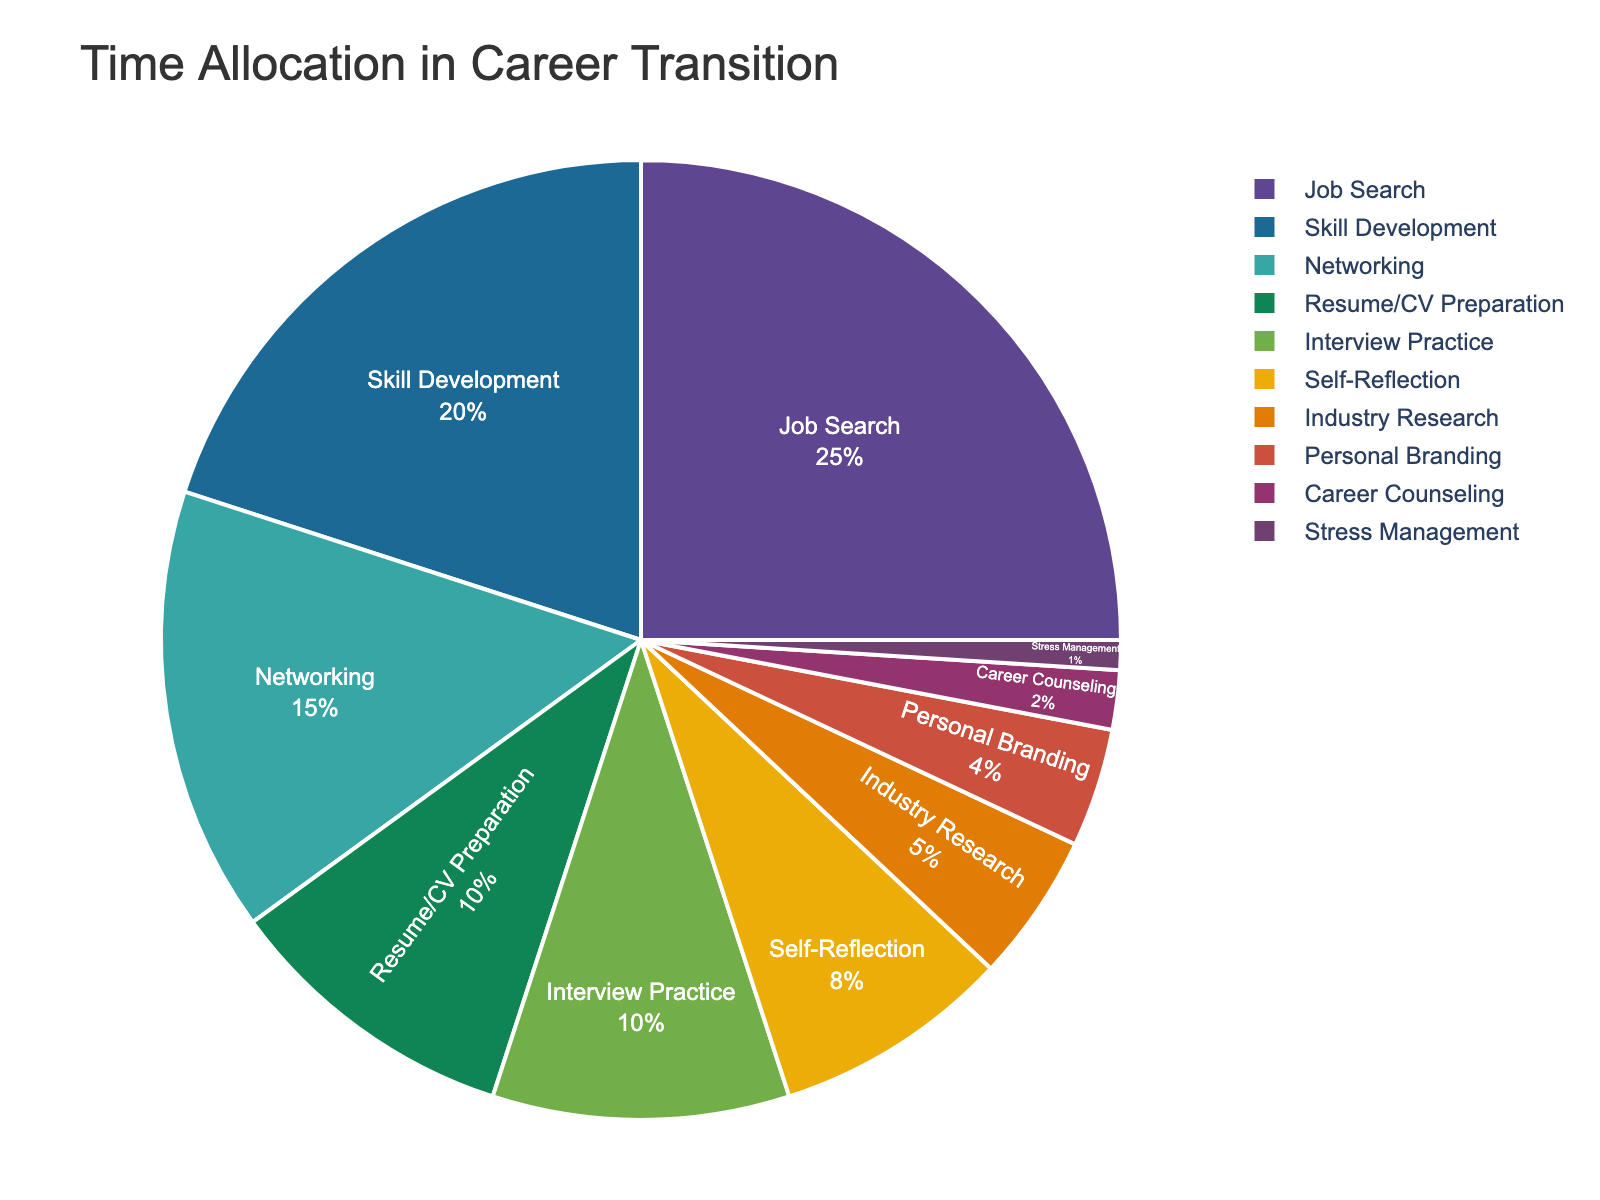Which activity takes up the largest percentage of time? The largest slice of the pie chart represents the activity with the highest percentage of time allocation. Job Search is the activity with the largest slice.
Answer: Job Search How much time is spent on Resume/CV Preparation compared to Networking? Resume/CV Preparation takes up 10%, while Networking takes up 15%. By comparing these values, we see that Networking is allocated more time.
Answer: Networking What is the combined time spent on Interview Practice and Industry Research? Interview Practice takes up 10% and Industry Research takes up 5%. Adding these percentages together gives 10% + 5% = 15%.
Answer: 15% Is more time allocated to Skill Development or Self-Reflection? And by how much? Skill Development takes up 20% while Self-Reflection takes up 8%. The difference is 20% - 8% = 12%. Skill Development is allocated more time by 12%.
Answer: Skill Development by 12% Which activity has the smallest allocation of time and what is its percentage? The smallest slice of the pie chart represents Stress Management, which has a 1% allocation.
Answer: Stress Management, 1% What is the combined percentage of time spent on activities related to direct job application processes (Resume/CV Preparation and Interview Practice)? Resume/CV Preparation is 10% and Interview Practice is 10%. Combined, they take up 10% + 10% = 20%.
Answer: 20% Among the activities, which one is the fourth most time-consuming, and what is its percentage? Going through the percentages in descending order: Job Search (25%), Skill Development (20%), Networking (15%), and then Resume/CV Preparation which is 10%.
Answer: Resume/CV Preparation, 10% How much more time is allocated to Self-Reflection compared to Career Counseling? Self-Reflection takes 8% of the time, while Career Counseling takes 2%. The difference is 8% - 2% = 6%.
Answer: 6% What is the total percentage of time spent on Personal Branding, Career Counseling, and Stress Management combined? Adding the percentages for Personal Branding (4%), Career Counseling (2%), and Stress Management (1%), we get 4% + 2% + 1% = 7%.
Answer: 7% If you add up the time spent on Job Search, Networking, and Industry Research, what percentage of the total time does that represent? Job Search is 25%, Networking is 15%, and Industry Research is 5%. Adding these together gives 25% + 15% + 5% = 45%.
Answer: 45% 